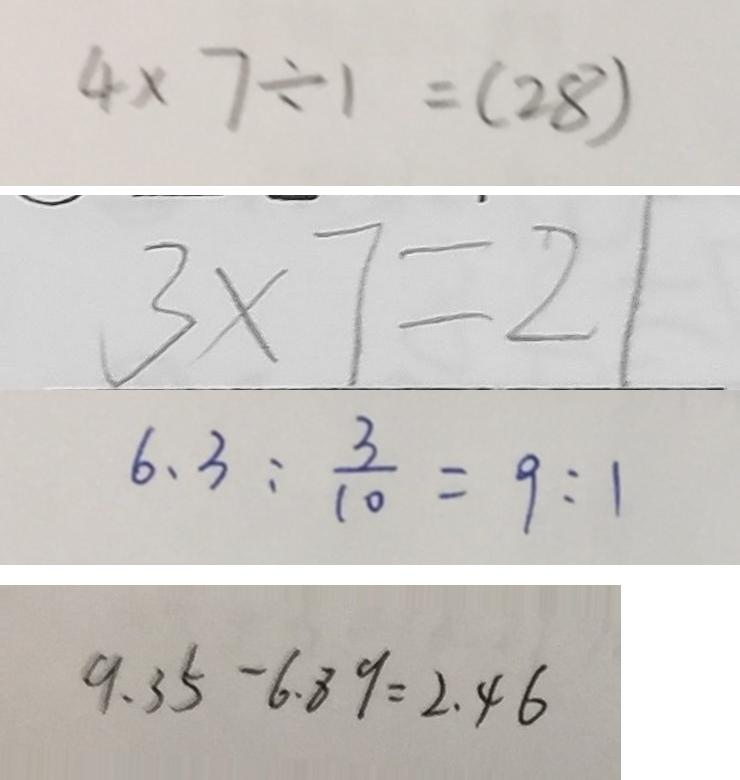<formula> <loc_0><loc_0><loc_500><loc_500>4 \times 7 \div 1 = ( 2 8 ) 
 3 \times 7 = 2 1 
 6 . 3 : \frac { 3 } { 1 0 } = 9 : 1 
 9 . 3 5 - 6 . 8 9 = 2 . 4 6</formula> 